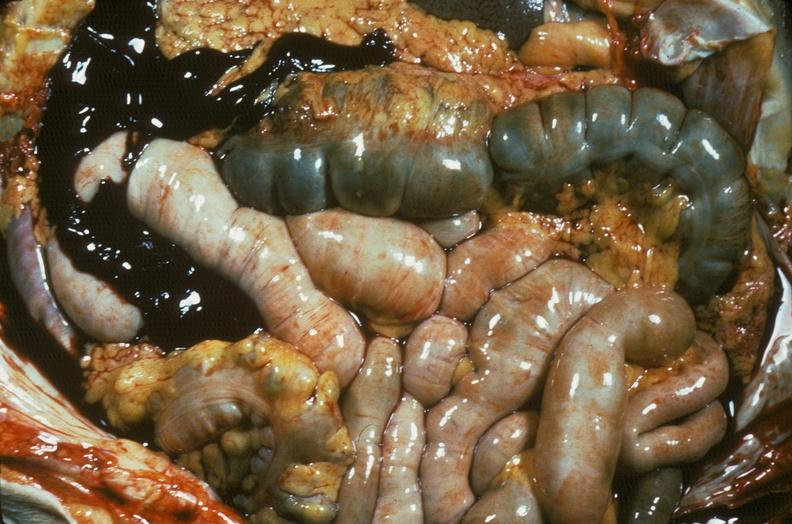does this image show hemorrhage secondary to ruptured aneurysm?
Answer the question using a single word or phrase. Yes 